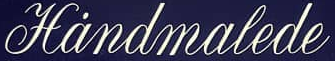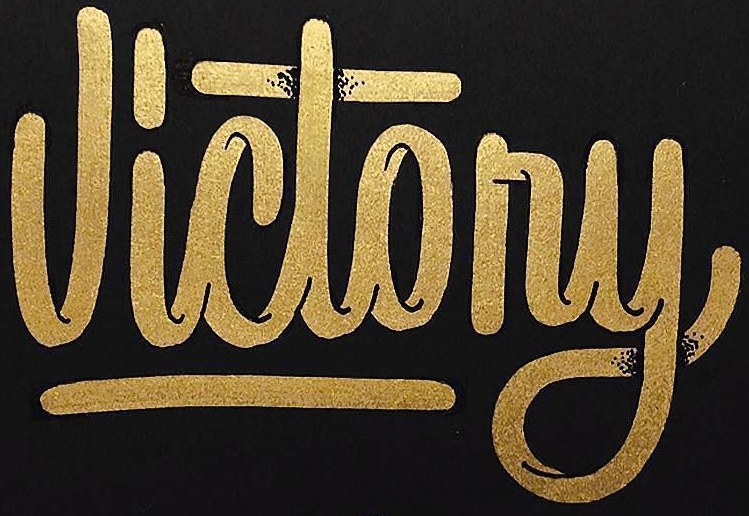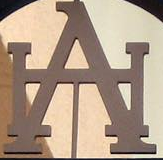What text appears in these images from left to right, separated by a semicolon? Hȧndmalede; Victony; HA 